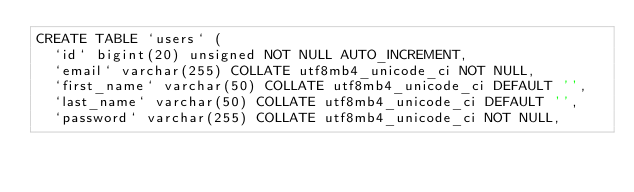Convert code to text. <code><loc_0><loc_0><loc_500><loc_500><_SQL_>CREATE TABLE `users` (
  `id` bigint(20) unsigned NOT NULL AUTO_INCREMENT,
  `email` varchar(255) COLLATE utf8mb4_unicode_ci NOT NULL,
  `first_name` varchar(50) COLLATE utf8mb4_unicode_ci DEFAULT '',
  `last_name` varchar(50) COLLATE utf8mb4_unicode_ci DEFAULT '',
  `password` varchar(255) COLLATE utf8mb4_unicode_ci NOT NULL,</code> 